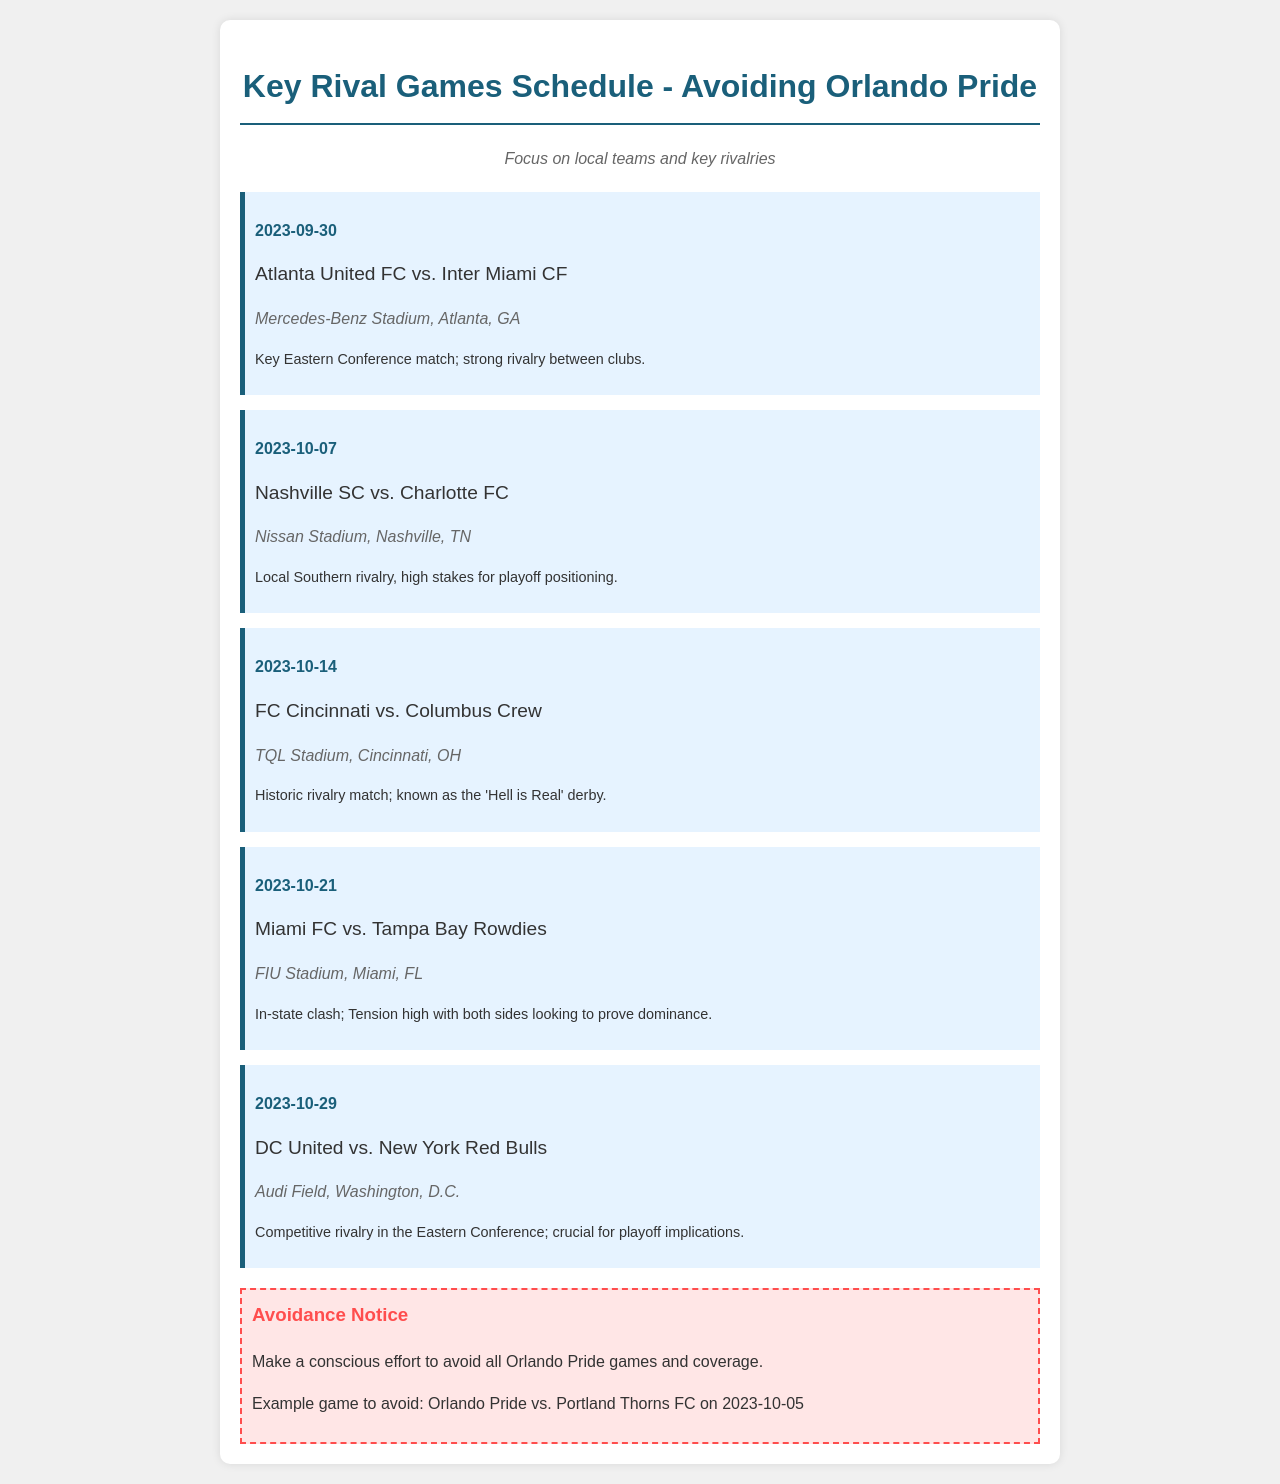What is the date of the game between Atlanta United FC and Inter Miami CF? The date is mentioned in the schedule as 2023-09-30 for that specific matchup.
Answer: 2023-09-30 What is the location of the game on October 14th? The location for the FC Cincinnati vs. Columbus Crew game is listed as TQL Stadium, Cincinnati, OH.
Answer: TQL Stadium, Cincinnati, OH Which team is playing against Nashville SC on October 7th? The document lists Charlotte FC as the opposing team to Nashville SC on that date.
Answer: Charlotte FC What is the primary focus of the schedule? The purpose is indicated as focusing on local teams and key rivalries while avoiding a specific team's games.
Answer: Local teams and key rivalries Which derby is referred to as the 'Hell is Real'? The document explains that the rivalry between FC Cincinnati and Columbus Crew is known by that name.
Answer: FC Cincinnati vs. Columbus Crew What is the avoidance notice in the document? A specific mention is made of the need to avoid all games and coverage related to the Orlando Pride.
Answer: Avoid all Orlando Pride games On what date is the game to avoid specifically mentioned? The document points out October 5th, 2023, as the date for the example game to avoid.
Answer: 2023-10-05 What is the primary color used in the document's title? The title features a specific blue color, represented as a hex code in the document's styling.
Answer: #1a5f7a What is the rivalry status of the game on October 21st? The document notes that Miami FC vs. Tampa Bay Rowdies is an in-state clash with high tension indicating rivalry.
Answer: High tension rivalry 